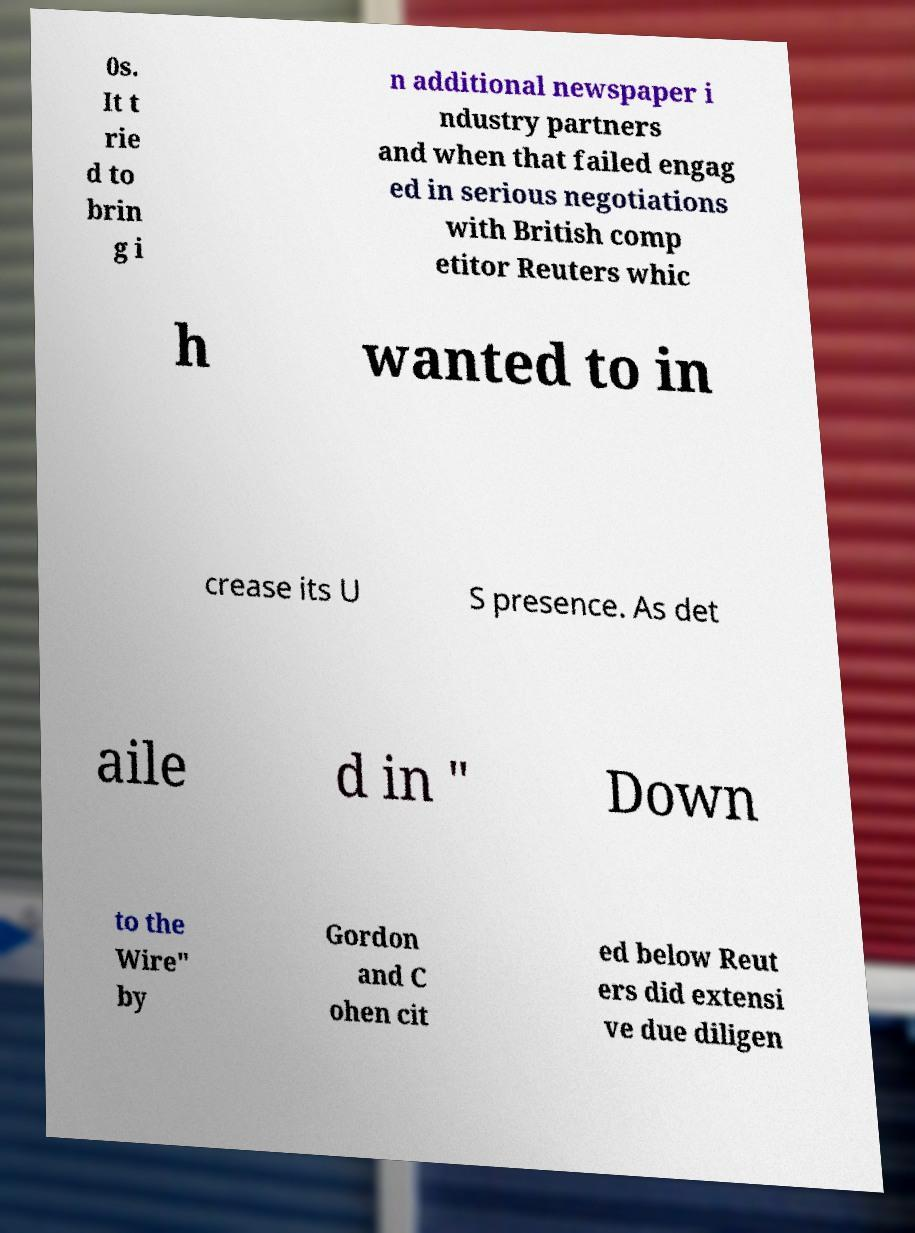Please read and relay the text visible in this image. What does it say? 0s. It t rie d to brin g i n additional newspaper i ndustry partners and when that failed engag ed in serious negotiations with British comp etitor Reuters whic h wanted to in crease its U S presence. As det aile d in " Down to the Wire" by Gordon and C ohen cit ed below Reut ers did extensi ve due diligen 